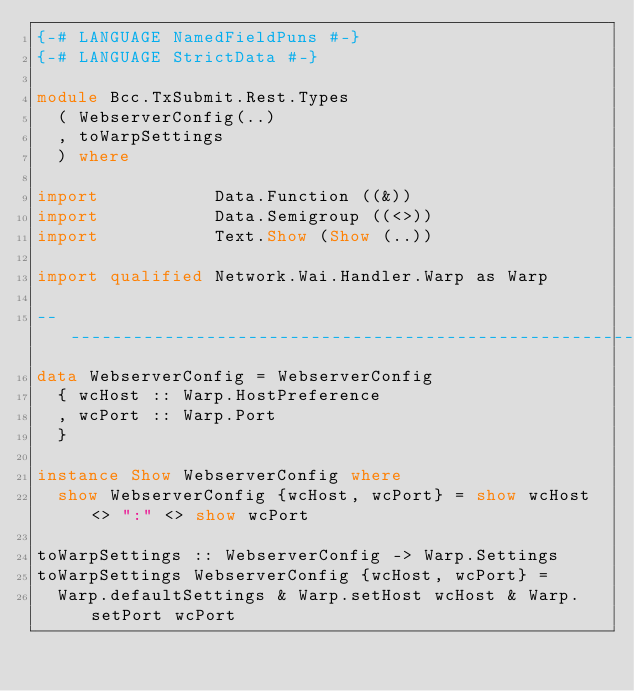Convert code to text. <code><loc_0><loc_0><loc_500><loc_500><_Haskell_>{-# LANGUAGE NamedFieldPuns #-}
{-# LANGUAGE StrictData #-}

module Bcc.TxSubmit.Rest.Types
  ( WebserverConfig(..)
  , toWarpSettings
  ) where

import           Data.Function ((&))
import           Data.Semigroup ((<>))
import           Text.Show (Show (..))

import qualified Network.Wai.Handler.Warp as Warp

------------------------------------------------------------
data WebserverConfig = WebserverConfig
  { wcHost :: Warp.HostPreference
  , wcPort :: Warp.Port
  }

instance Show WebserverConfig where
  show WebserverConfig {wcHost, wcPort} = show wcHost <> ":" <> show wcPort

toWarpSettings :: WebserverConfig -> Warp.Settings
toWarpSettings WebserverConfig {wcHost, wcPort} =
  Warp.defaultSettings & Warp.setHost wcHost & Warp.setPort wcPort
</code> 